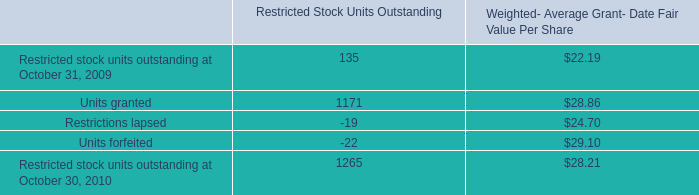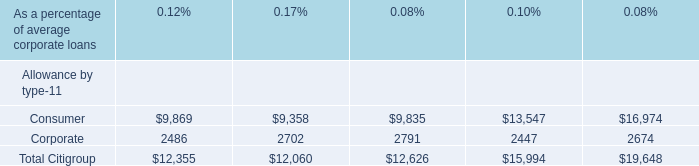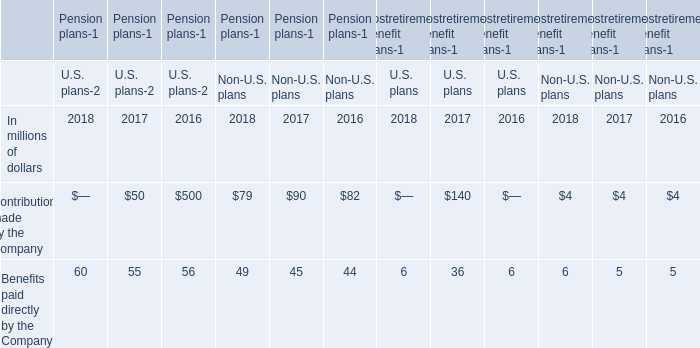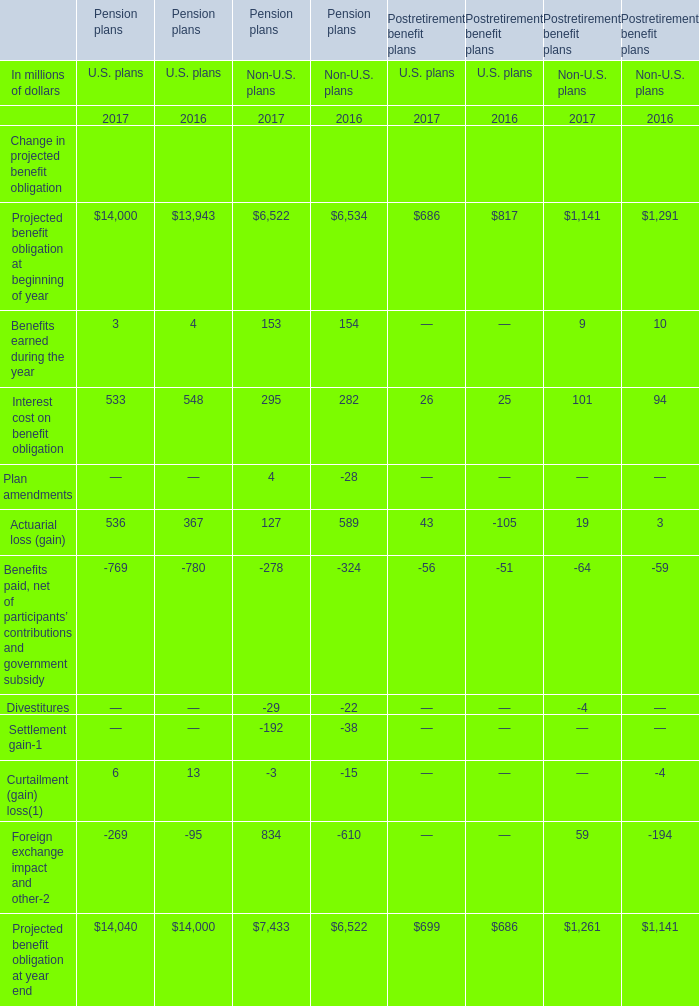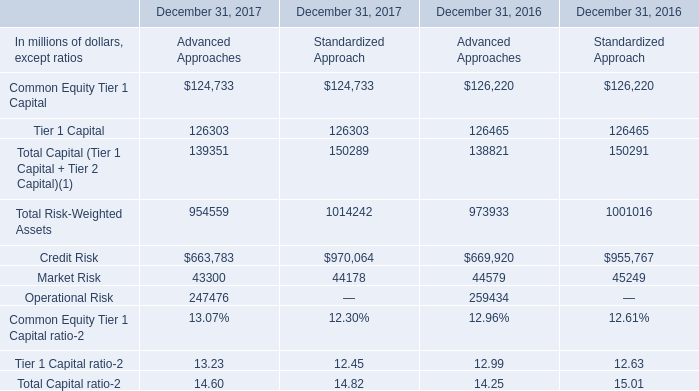What's the growth rate of Actuarial loss (gain) of U.S. Pension plans in 2017? 
Computations: ((536 - 367) / 367)
Answer: 0.46049. 